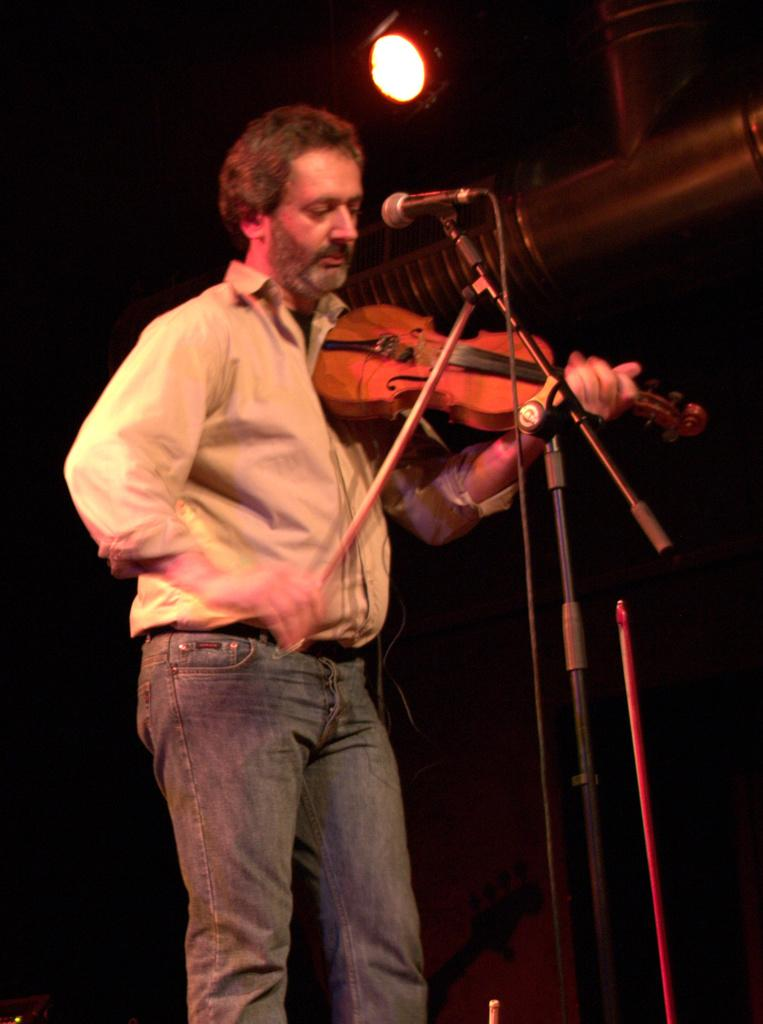What is the main subject of the image? The main subject of the image is a man. What is the man doing in the image? The man is standing and playing a violin. What objects are present in the image besides the man? There is a microphone and a light in the image. How would you describe the lighting in the image? The background of the image is dark. What type of harmony can be heard coming from the crook in the image? There is no crook present in the image, and therefore no harmony can be heard from it. 